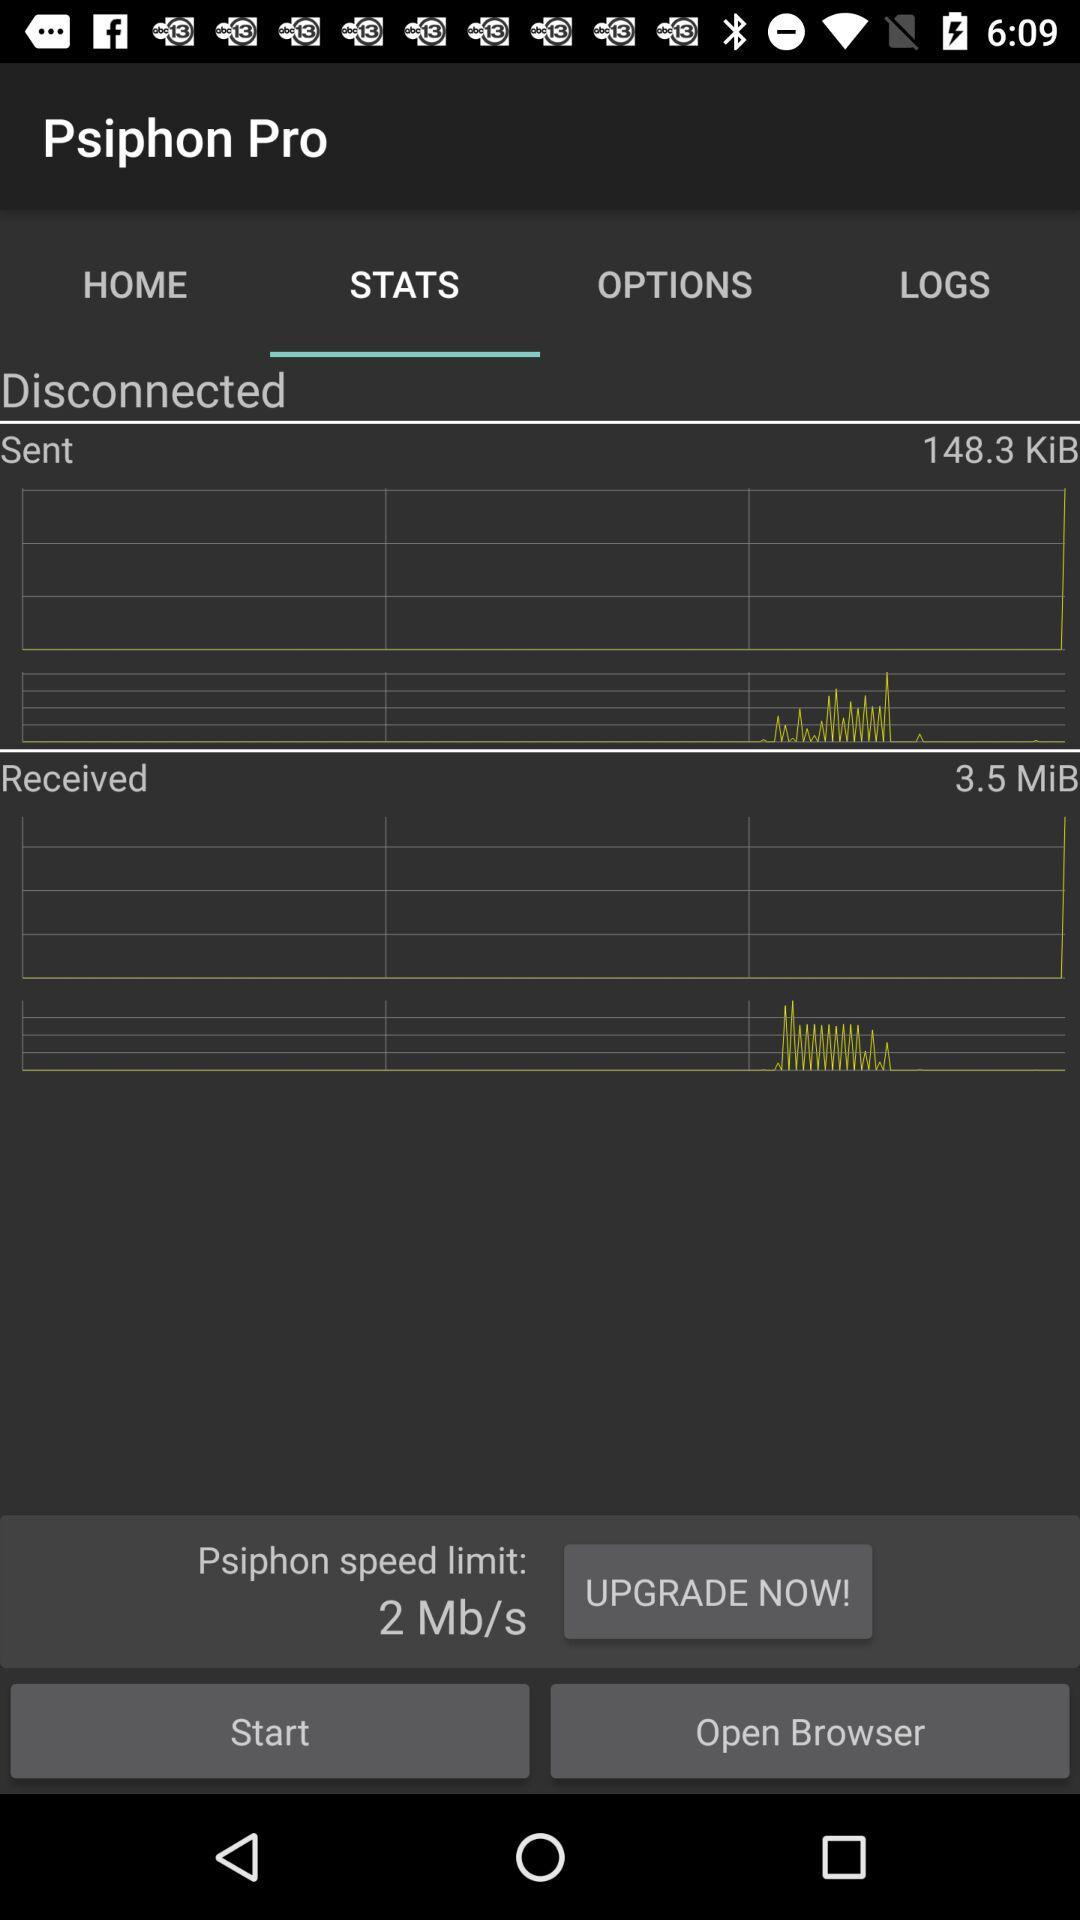What is the Psiphon speed limit? The Psiphon speed limit is 2 Megabit per second. 